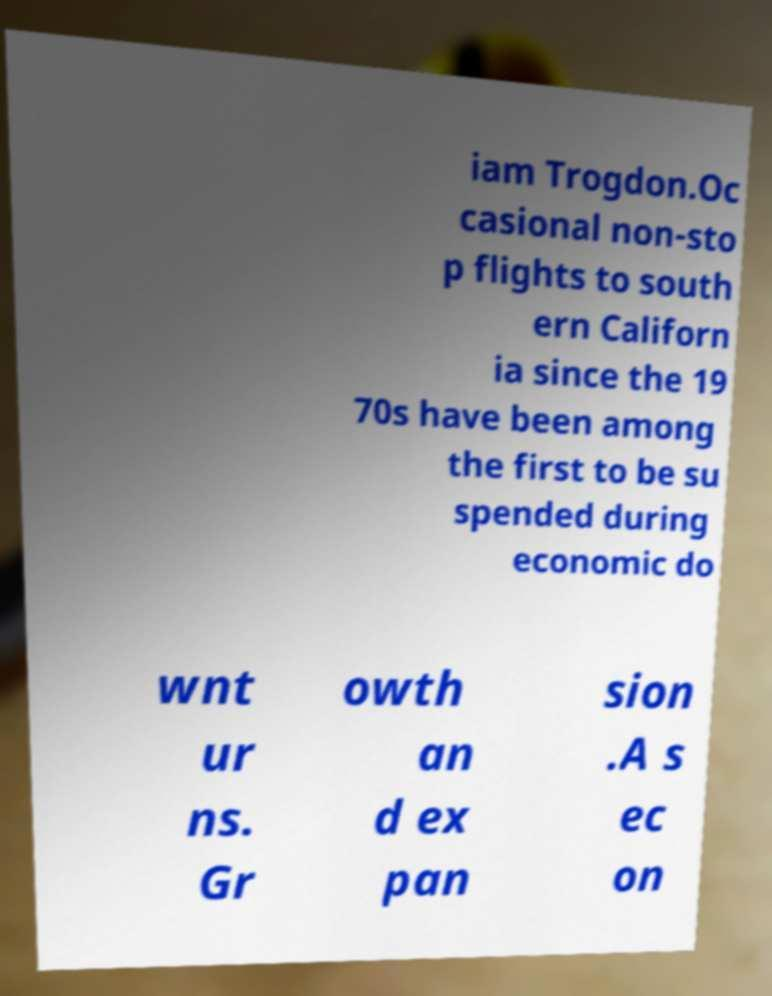Could you assist in decoding the text presented in this image and type it out clearly? iam Trogdon.Oc casional non-sto p flights to south ern Californ ia since the 19 70s have been among the first to be su spended during economic do wnt ur ns. Gr owth an d ex pan sion .A s ec on 